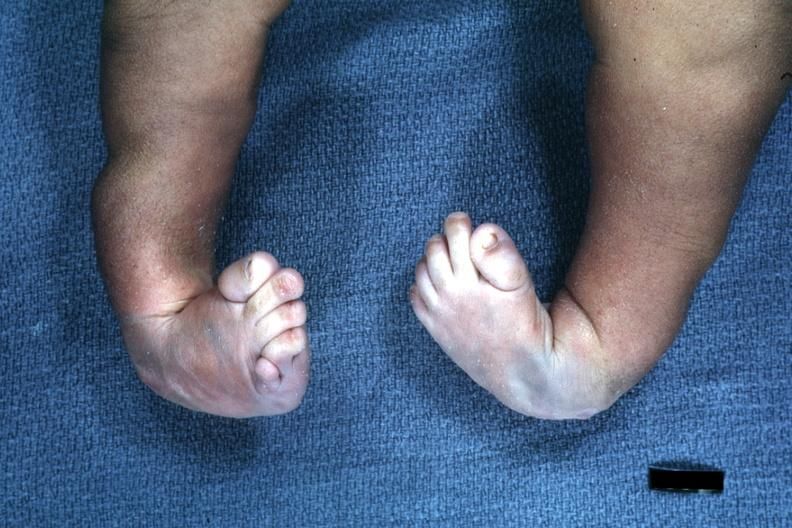does side show infant with club feet?
Answer the question using a single word or phrase. No 